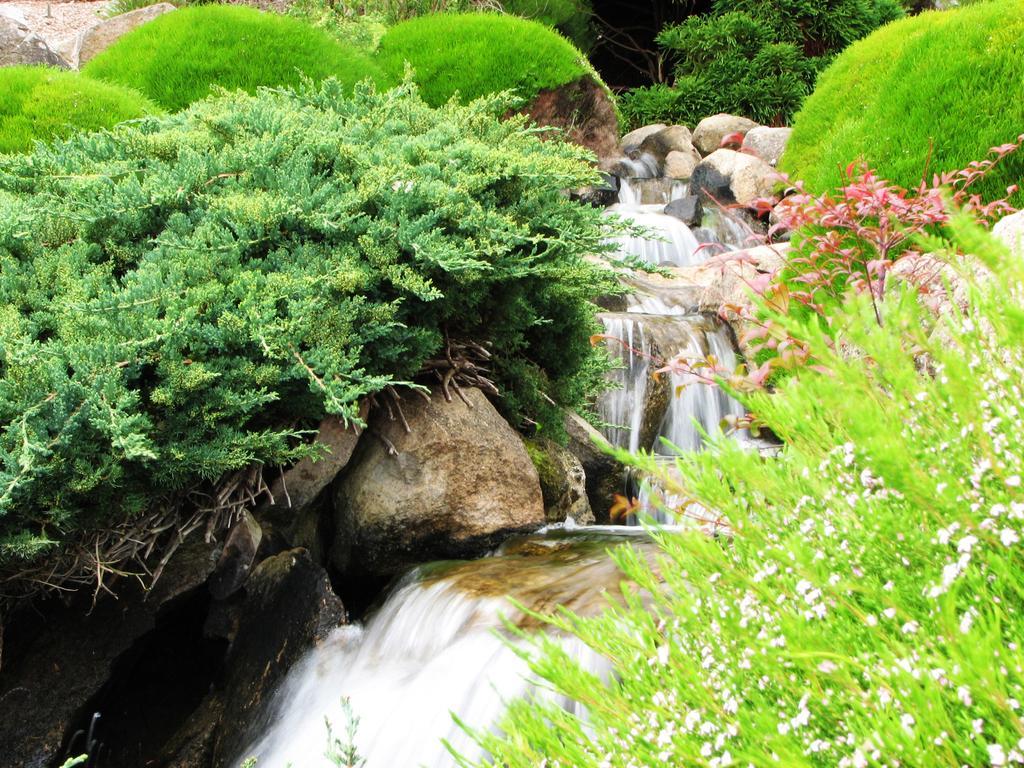How would you summarize this image in a sentence or two? In this image we can see plants, grass, stones and waterfall. 